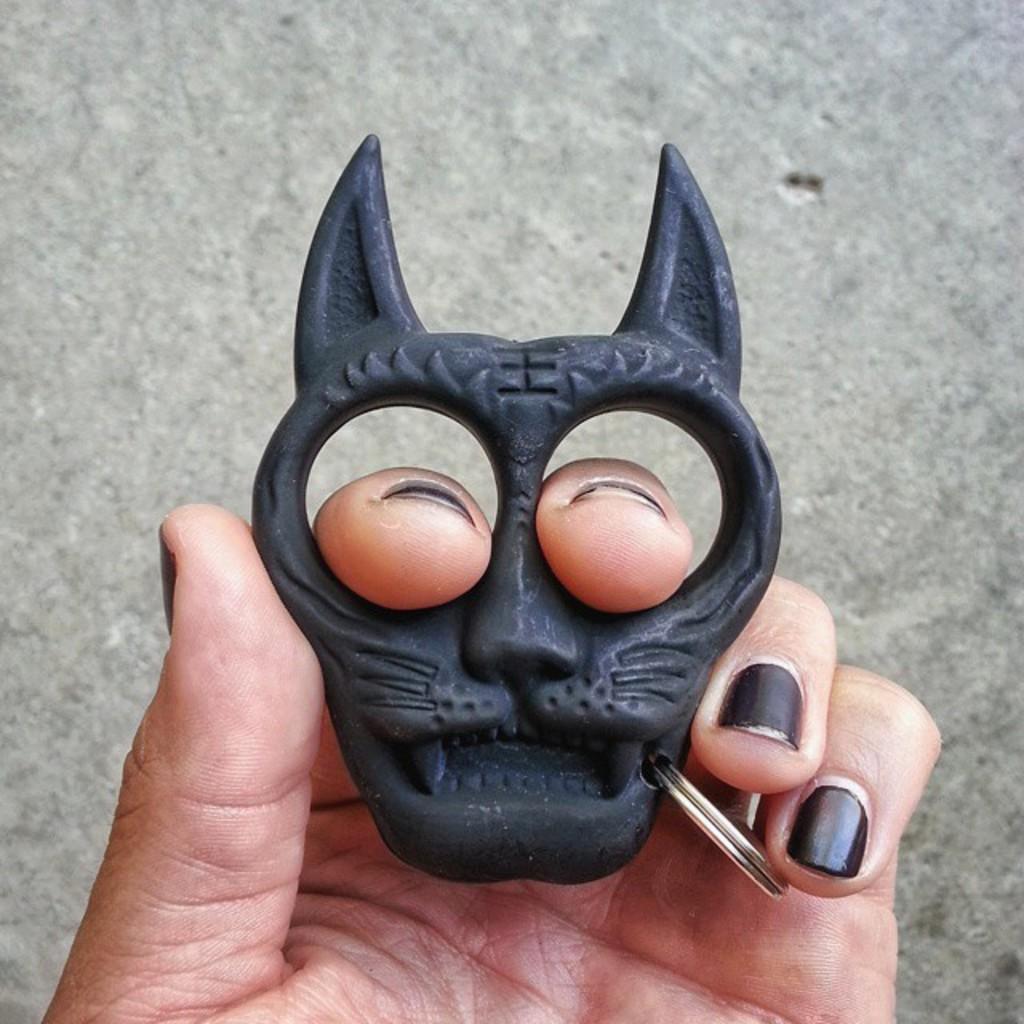Describe this image in one or two sentences. In this image we can see keychain in person's hand. 